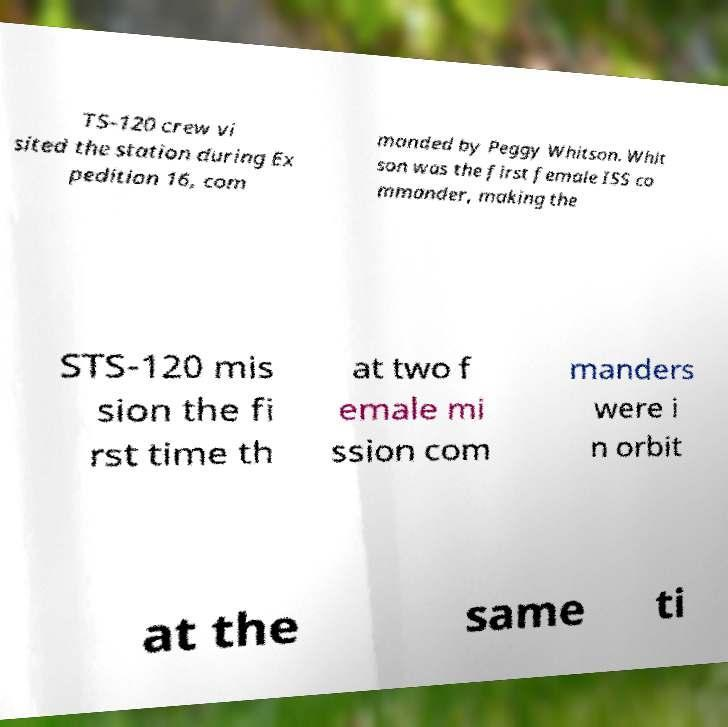What messages or text are displayed in this image? I need them in a readable, typed format. TS-120 crew vi sited the station during Ex pedition 16, com manded by Peggy Whitson. Whit son was the first female ISS co mmander, making the STS-120 mis sion the fi rst time th at two f emale mi ssion com manders were i n orbit at the same ti 